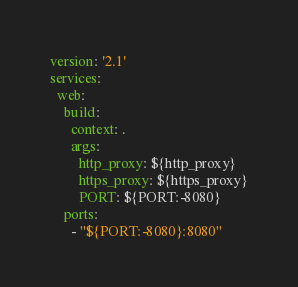<code> <loc_0><loc_0><loc_500><loc_500><_YAML_>version: '2.1'
services:
  web:
    build:
      context: .
      args:
        http_proxy: ${http_proxy}
        https_proxy: ${https_proxy}
        PORT: ${PORT:-8080}
    ports:
      - "${PORT:-8080}:8080"
</code> 